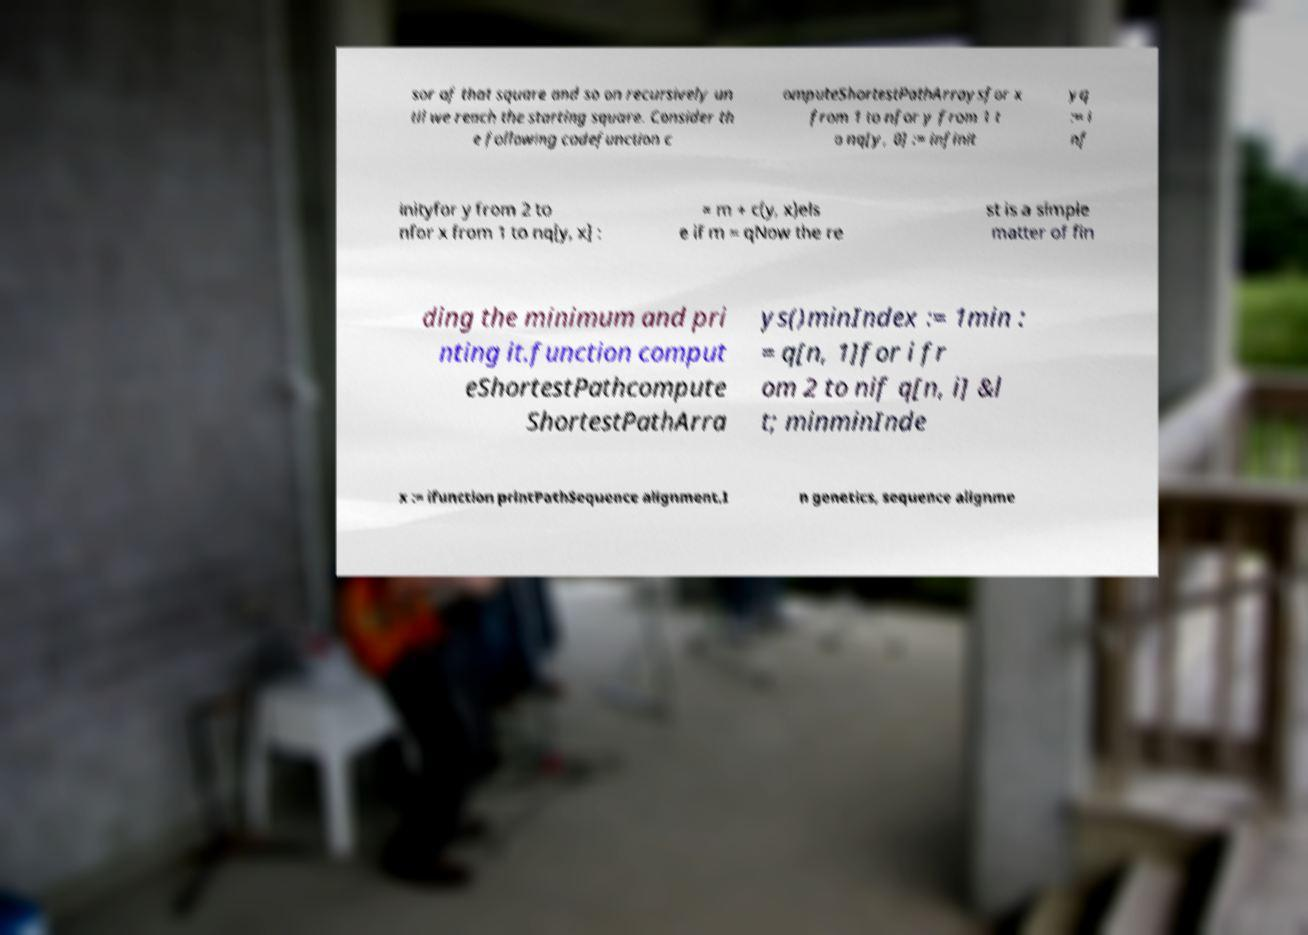Can you accurately transcribe the text from the provided image for me? sor of that square and so on recursively un til we reach the starting square. Consider th e following codefunction c omputeShortestPathArraysfor x from 1 to nfor y from 1 t o nq[y, 0] := infinit yq := i nf inityfor y from 2 to nfor x from 1 to nq[y, x] : = m + c(y, x)els e if m = qNow the re st is a simple matter of fin ding the minimum and pri nting it.function comput eShortestPathcompute ShortestPathArra ys()minIndex := 1min : = q[n, 1]for i fr om 2 to nif q[n, i] &l t; minminInde x := ifunction printPathSequence alignment.I n genetics, sequence alignme 